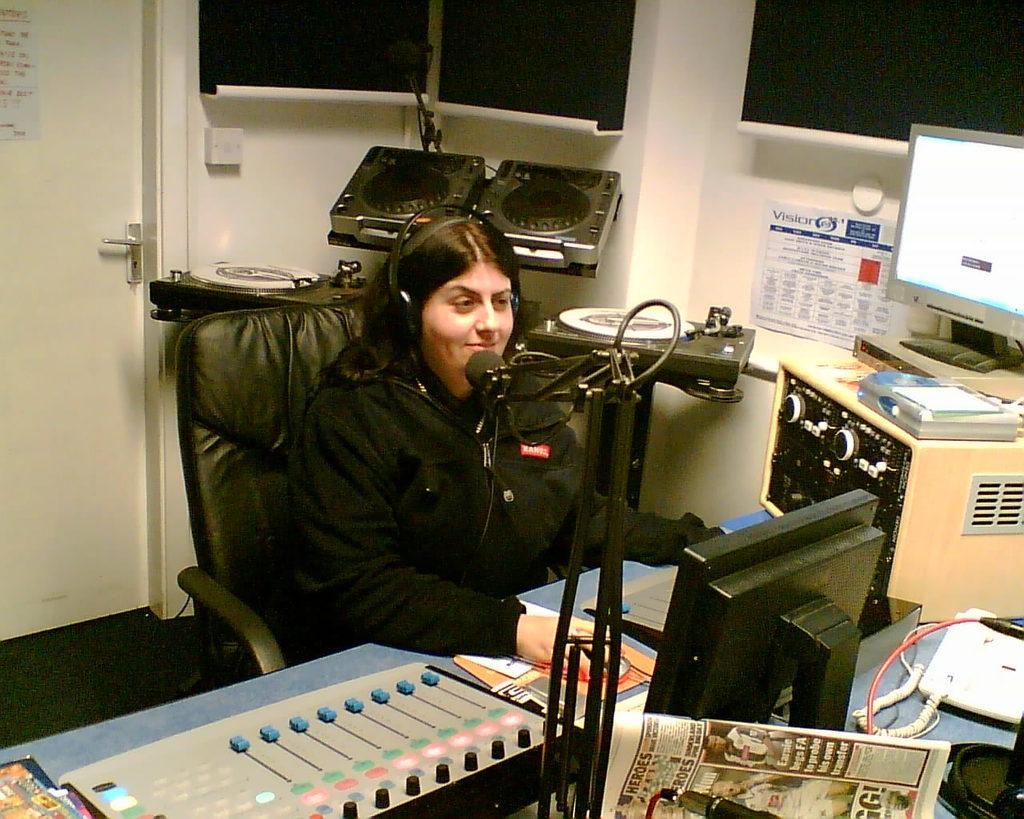In one or two sentences, can you explain what this image depicts? In this picture we can see a woman sitting on a chair and smiling. In front of her we can see a telephone, mouse, newspaper, devices, books and cables. In the background we can see the wall, door, posters, devices and some objects. 